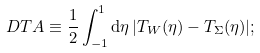Convert formula to latex. <formula><loc_0><loc_0><loc_500><loc_500>\ D T A \equiv \frac { 1 } { 2 } \int ^ { 1 } _ { - 1 } { \mathrm d } \eta \, | T _ { W } ( \eta ) - T _ { \Sigma } ( \eta ) | ;</formula> 